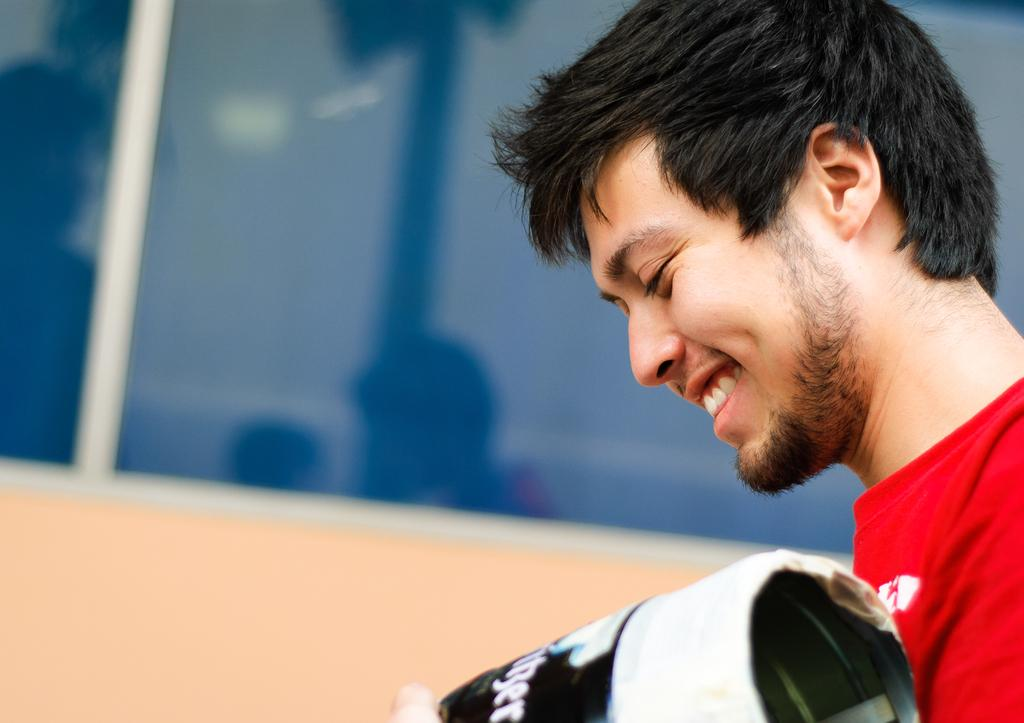What is present in the image? There is a person in the image. What is the person doing in the image? The person is holding an object. Can you describe any architectural features in the image? There is a glass window in the image. What type of chess piece is the person holding in the image? There is no chess piece present in the image; the person is holding an unspecified object. How does the person's digestion process appear in the image? There is no indication of the person's digestion process in the image, as it focuses on the person holding an object and the presence of a glass window. 